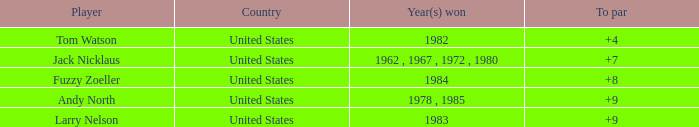Can you give me this table as a dict? {'header': ['Player', 'Country', 'Year(s) won', 'To par'], 'rows': [['Tom Watson', 'United States', '1982', '+4'], ['Jack Nicklaus', 'United States', '1962 , 1967 , 1972 , 1980', '+7'], ['Fuzzy Zoeller', 'United States', '1984', '+8'], ['Andy North', 'United States', '1978 , 1985', '+9'], ['Larry Nelson', 'United States', '1983', '+9']]} What is the to par for player andy north when his total is greater than 153? 0.0. 